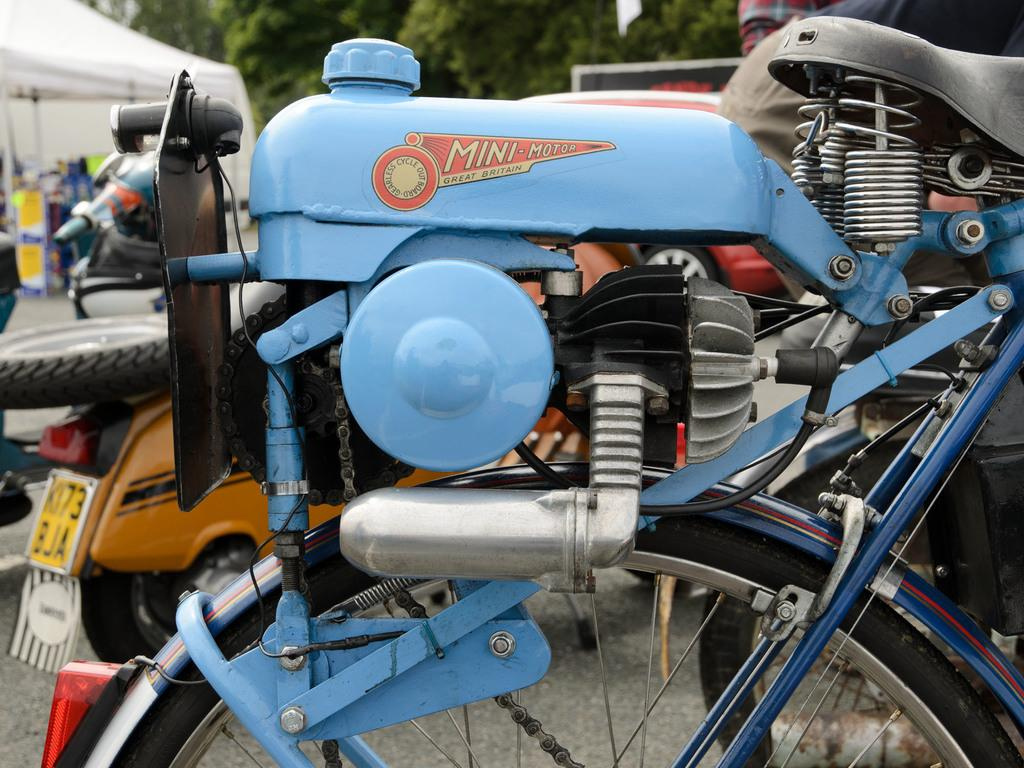What can be seen on the road in the image? There are vehicles on the road in the image. What type of temporary shelter is present in the image? There is a tent in the image. What can be seen inside the tent? There are objects visible inside the tent. What type of natural vegetation is visible in the background of the image? Trees are present in the background of the image. How many buttons are visible on the passenger in the image? There is no passenger present in the image, and therefore no buttons can be observed. What type of bat is flying around the tent in the image? There is no bat present in the image; it features vehicles on the road, a tent, and objects inside the tent. 